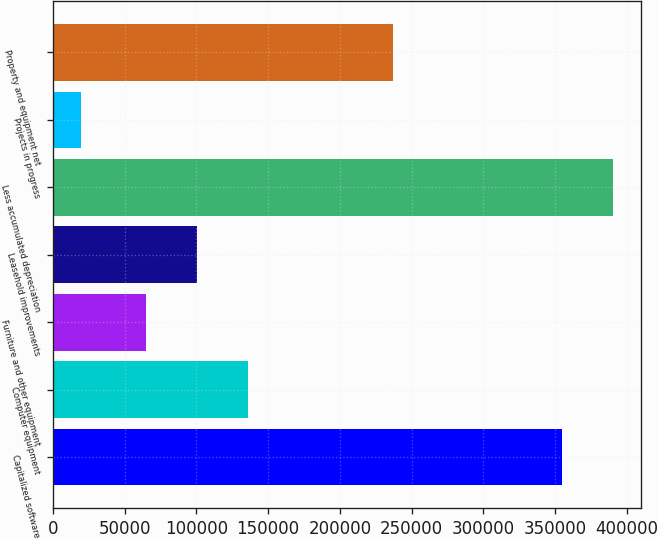Convert chart. <chart><loc_0><loc_0><loc_500><loc_500><bar_chart><fcel>Capitalized software<fcel>Computer equipment<fcel>Furniture and other equipment<fcel>Leasehold improvements<fcel>Less accumulated depreciation<fcel>Projects in progress<fcel>Property and equipment net<nl><fcel>355088<fcel>135628<fcel>65098<fcel>100363<fcel>390353<fcel>19401<fcel>236820<nl></chart> 